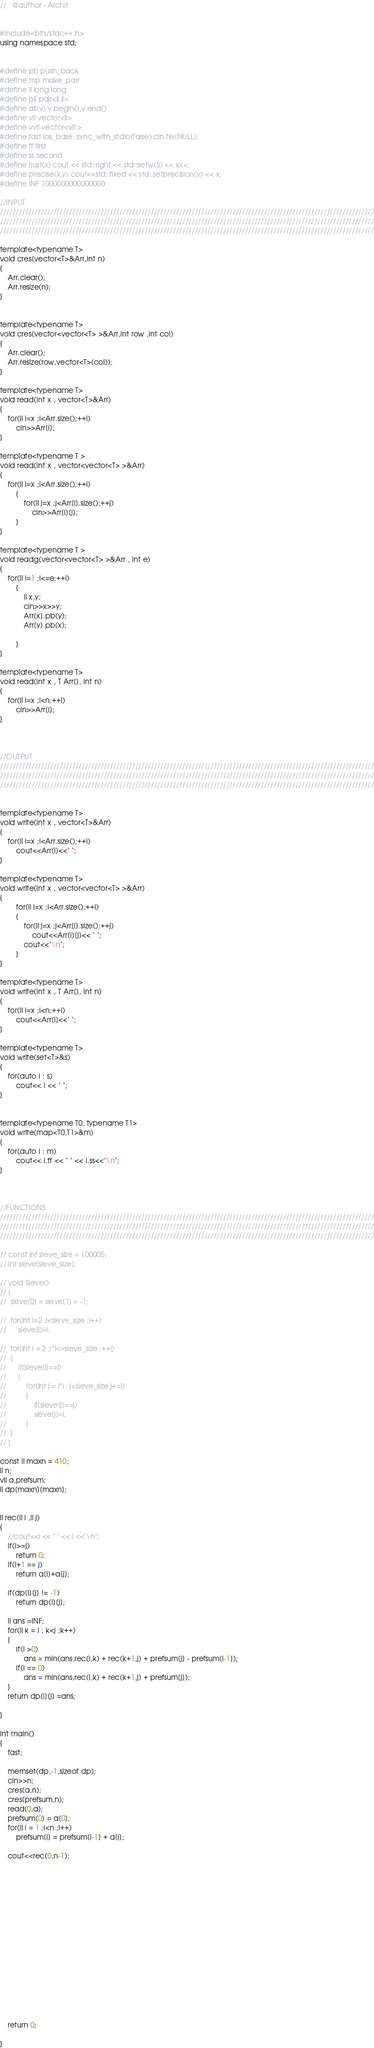Convert code to text. <code><loc_0><loc_0><loc_500><loc_500><_C++_>



//   @author - Archit


#include<bits/stdc++.h>
using namespace std;


#define pb push_back
#define mp make_pair
#define ll long long
#define pll pair<ll,ll> 
#define all(v) v.begin(),v.end()
#define vll vector<ll> 
#define vvll vector<vll >
#define fast ios_base::sync_with_stdio(false);cin.tie(NULL);
#define ff first
#define ss second 
#define rjust(x) cout << std::right << std::setw(5) << x<<;
#define precise(x,y) cout<<std::fixed << std::setprecision(y) << x;
#define INF 1000000000000000

//INPUT
///////////////////////////////////////////////////////////////////////////////////////////////////////////////////////
///////////////////////////////////////////////////////////////////////////////////////////////////////////////////////
///////////////////////////////////////////////////////////////////////////////////////////////////////////////////////

template<typename T>
void cres(vector<T>&Arr,int n)
{
	Arr.clear();
	Arr.resize(n);
}


template<typename T>
void cres(vector<vector<T> >&Arr,int row ,int col)
{
	Arr.clear();
	Arr.resize(row,vector<T>(col));
}

template<typename T>
void read(int x , vector<T>&Arr)
{
	for(ll i=x ;i<Arr.size();++i)
		cin>>Arr[i];
}

template<typename T >
void read(int x , vector<vector<T> >&Arr)
{
	for(ll i=x ;i<Arr.size();++i)
		{
			for(ll j=x ;j<Arr[i].size();++j)
				cin>>Arr[i][j];
		}
}

template<typename T >
void readg(vector<vector<T> >&Arr , int e)
{
	for(ll i=1 ;i<=e;++i)
		{
			ll x,y;
			cin>>x>>y;
			Arr[x].pb(y);
			Arr[y].pb(x);

		}
}

template<typename T>
void read(int x , T Arr[], int n)
{
	for(ll i=x ;i<n;++i)
		cin>>Arr[i];
}



//OUTPUT
///////////////////////////////////////////////////////////////////////////////////////////////////////////////////////
///////////////////////////////////////////////////////////////////////////////////////////////////////////////////////
///////////////////////////////////////////////////////////////////////////////////////////////////////////////////////


template<typename T>
void write(int x , vector<T>&Arr)
{
	for(ll i=x ;i<Arr.size();++i)
		cout<<Arr[i]<<" ";
}

template<typename T>
void write(int x , vector<vector<T> >&Arr)
{
		for(ll i=x ;i<Arr.size();++i)
		{
			for(ll j=x ;j<Arr[i].size();++j)
				cout<<Arr[i][j]<< " ";
			cout<<"\n";
		}
}

template<typename T>
void write(int x , T Arr[], int n)
{
	for(ll i=x ;i<n;++i)
		cout<<Arr[i]<<" ";
}

template<typename T>
void write(set<T>&s)
{
	for(auto i : s) 
		cout<< i << " ";
}


template<typename T0, typename T1>
void write(map<T0,T1>&m)
{
	for(auto i : m) 
		cout<< i.ff << " " << i.ss<<"\n";
}



//FUNCTIONS
///////////////////////////////////////////////////////////////////////////////////////////////////////////////////////
///////////////////////////////////////////////////////////////////////////////////////////////////////////////////////
///////////////////////////////////////////////////////////////////////////////////////////////////////////////////////

// const int sieve_size = 100005;
// int sieve[sieve_size];

// void Sieve()
// {
// 	sieve[0] = sieve[1] = -1;
	
// 	for(int i=2 ;i<sieve_size ;i++)
// 		sieve[i]=i;

// 	for(int i = 2 ;i*i<=sieve_size ;++i)
// 	{
// 		if(sieve[i]==i)
// 		{
// 			for(int j = i*i ; j<sieve_size;j+=i)
// 			{
// 				if(sieve[j]==j)
// 				sieve[j]=i;
// 			}
// 	}
// }

const ll maxn = 410;
ll n;
vll a,prefsum;
ll dp[maxn][maxn];


ll rec(ll i ,ll j)
{
	//cout<<i << " " << j <<"\n";
	if(i>=j)
		return 0;
	if(i+1 == j)
		return a[i]+a[j];

	if(dp[i][j] != -1)
		return dp[i][j];

	ll ans =INF;
	for(ll k = i ; k<j ;k++)
	{
		if(i >0)
			ans = min(ans,rec(i,k) + rec(k+1,j) + prefsum[j] - prefsum[i-1]);
		if(i == 0)
			ans = min(ans,rec(i,k) + rec(k+1,j) + prefsum[j]);
	}
	return dp[i][j] =ans;

}

int main()
{
	fast;

	memset(dp,-1,sizeof dp);
	cin>>n;
	cres(a,n);
	cres(prefsum,n);
	read(0,a);
	prefsum[0] = a[0];
	for(ll i = 1 ;i<n ;i++)
		prefsum[i] = prefsum[i-1] + a[i];

	cout<<rec(0,n-1);

















	return 0;
	
}


</code> 